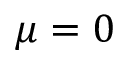<formula> <loc_0><loc_0><loc_500><loc_500>\mu = 0</formula> 